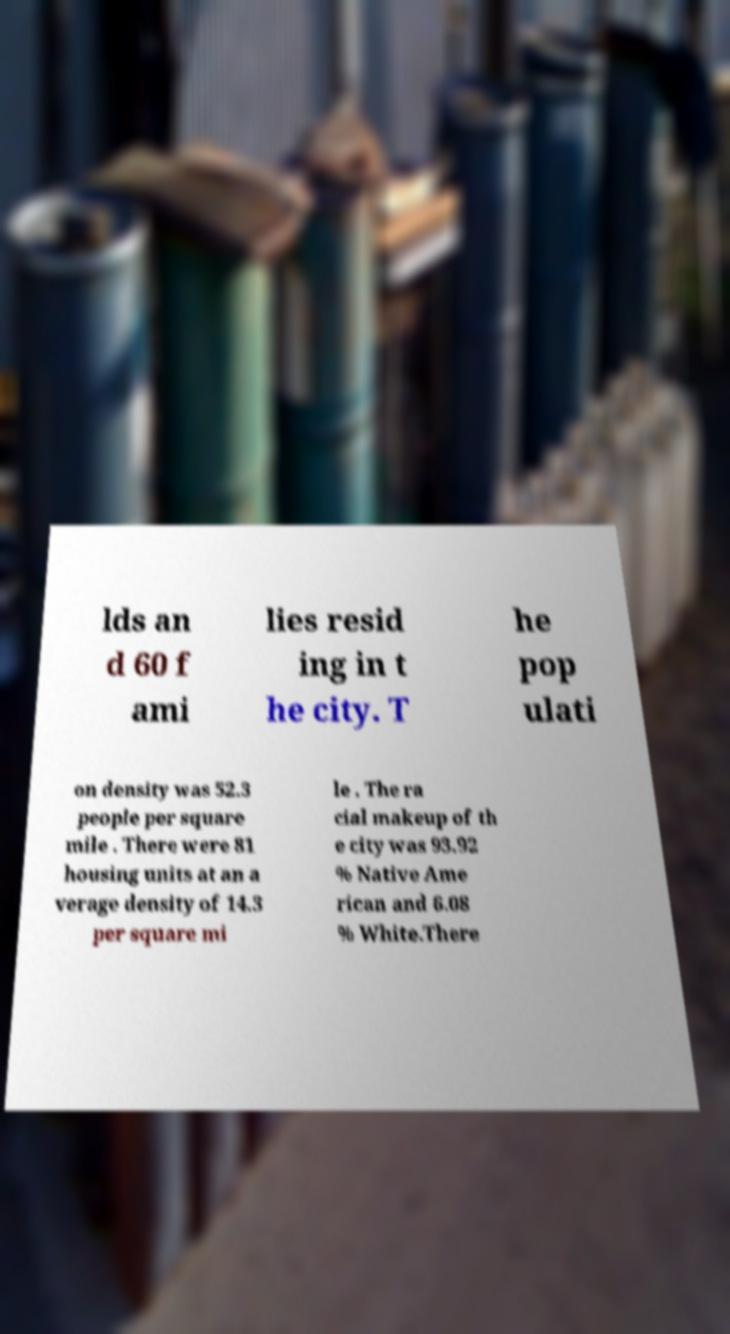There's text embedded in this image that I need extracted. Can you transcribe it verbatim? lds an d 60 f ami lies resid ing in t he city. T he pop ulati on density was 52.3 people per square mile . There were 81 housing units at an a verage density of 14.3 per square mi le . The ra cial makeup of th e city was 93.92 % Native Ame rican and 6.08 % White.There 